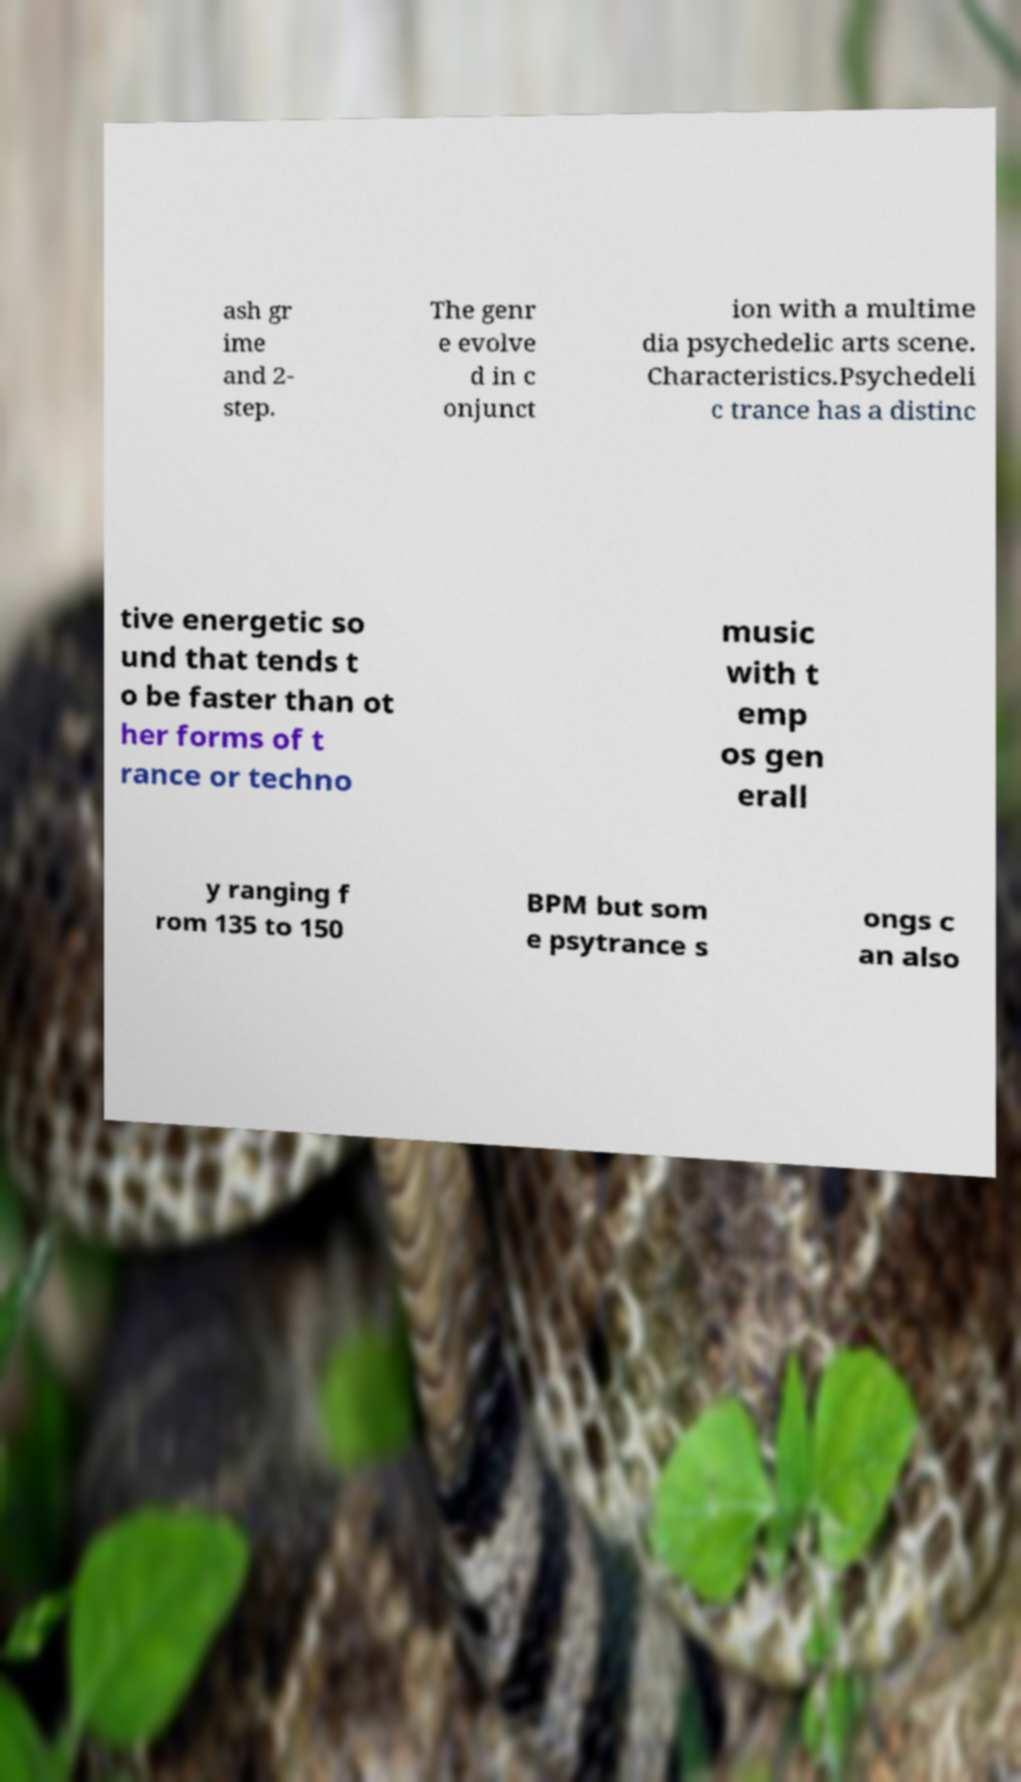I need the written content from this picture converted into text. Can you do that? ash gr ime and 2- step. The genr e evolve d in c onjunct ion with a multime dia psychedelic arts scene. Characteristics.Psychedeli c trance has a distinc tive energetic so und that tends t o be faster than ot her forms of t rance or techno music with t emp os gen erall y ranging f rom 135 to 150 BPM but som e psytrance s ongs c an also 